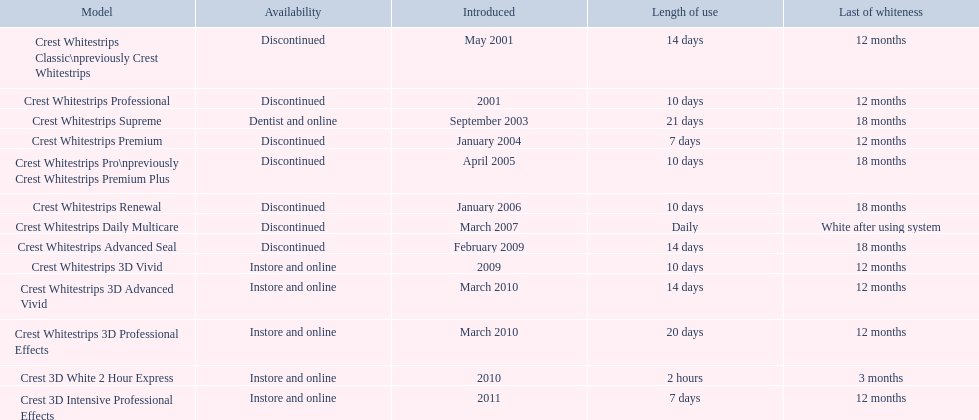What merchandise is enumerated? Crest Whitestrips Classic\npreviously Crest Whitestrips, Crest Whitestrips Professional, Crest Whitestrips Supreme, Crest Whitestrips Premium, Crest Whitestrips Pro\npreviously Crest Whitestrips Premium Plus, Crest Whitestrips Renewal, Crest Whitestrips Daily Multicare, Crest Whitestrips Advanced Seal, Crest Whitestrips 3D Vivid, Crest Whitestrips 3D Advanced Vivid, Crest Whitestrips 3D Professional Effects, Crest 3D White 2 Hour Express, Crest 3D Intensive Professional Effects. Out of these, which were presented in march 2010? Crest Whitestrips 3D Advanced Vivid, Crest Whitestrips 3D Professional Effects. Among them, which lacked 3d advanced vivid capabilities? Crest Whitestrips 3D Professional Effects. What varieties of crest whitestrips have been launched? Crest Whitestrips Classic\npreviously Crest Whitestrips, Crest Whitestrips Professional, Crest Whitestrips Supreme, Crest Whitestrips Premium, Crest Whitestrips Pro\npreviously Crest Whitestrips Premium Plus, Crest Whitestrips Renewal, Crest Whitestrips Daily Multicare, Crest Whitestrips Advanced Seal, Crest Whitestrips 3D Vivid, Crest Whitestrips 3D Advanced Vivid, Crest Whitestrips 3D Professional Effects, Crest 3D White 2 Hour Express, Crest 3D Intensive Professional Effects. What was the period of use for each variety? 14 days, 10 days, 21 days, 7 days, 10 days, 10 days, Daily, 14 days, 10 days, 14 days, 20 days, 2 hours, 7 days. And how long did each remain? 12 months, 12 months, 18 months, 12 months, 18 months, 18 months, White after using system, 18 months, 12 months, 12 months, 12 months, 3 months, 12 months. Of those models, which remained the longest with the longest period of use? Crest Whitestrips Supreme. 